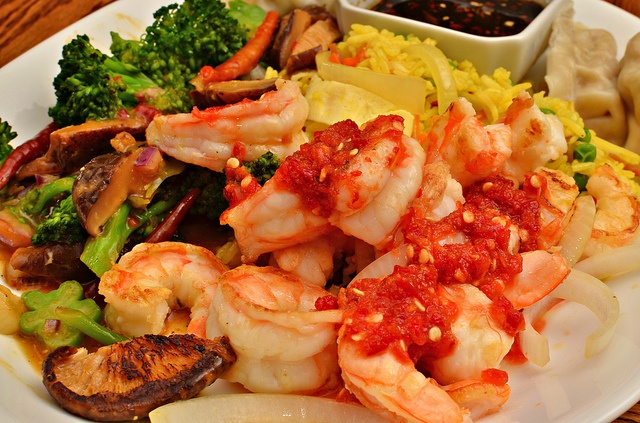Describe the objects in this image and their specific colors. I can see broccoli in maroon, black, darkgreen, and olive tones, broccoli in maroon, black, and olive tones, bowl in maroon, olive, tan, and beige tones, broccoli in maroon and olive tones, and carrot in maroon, red, brown, and black tones in this image. 